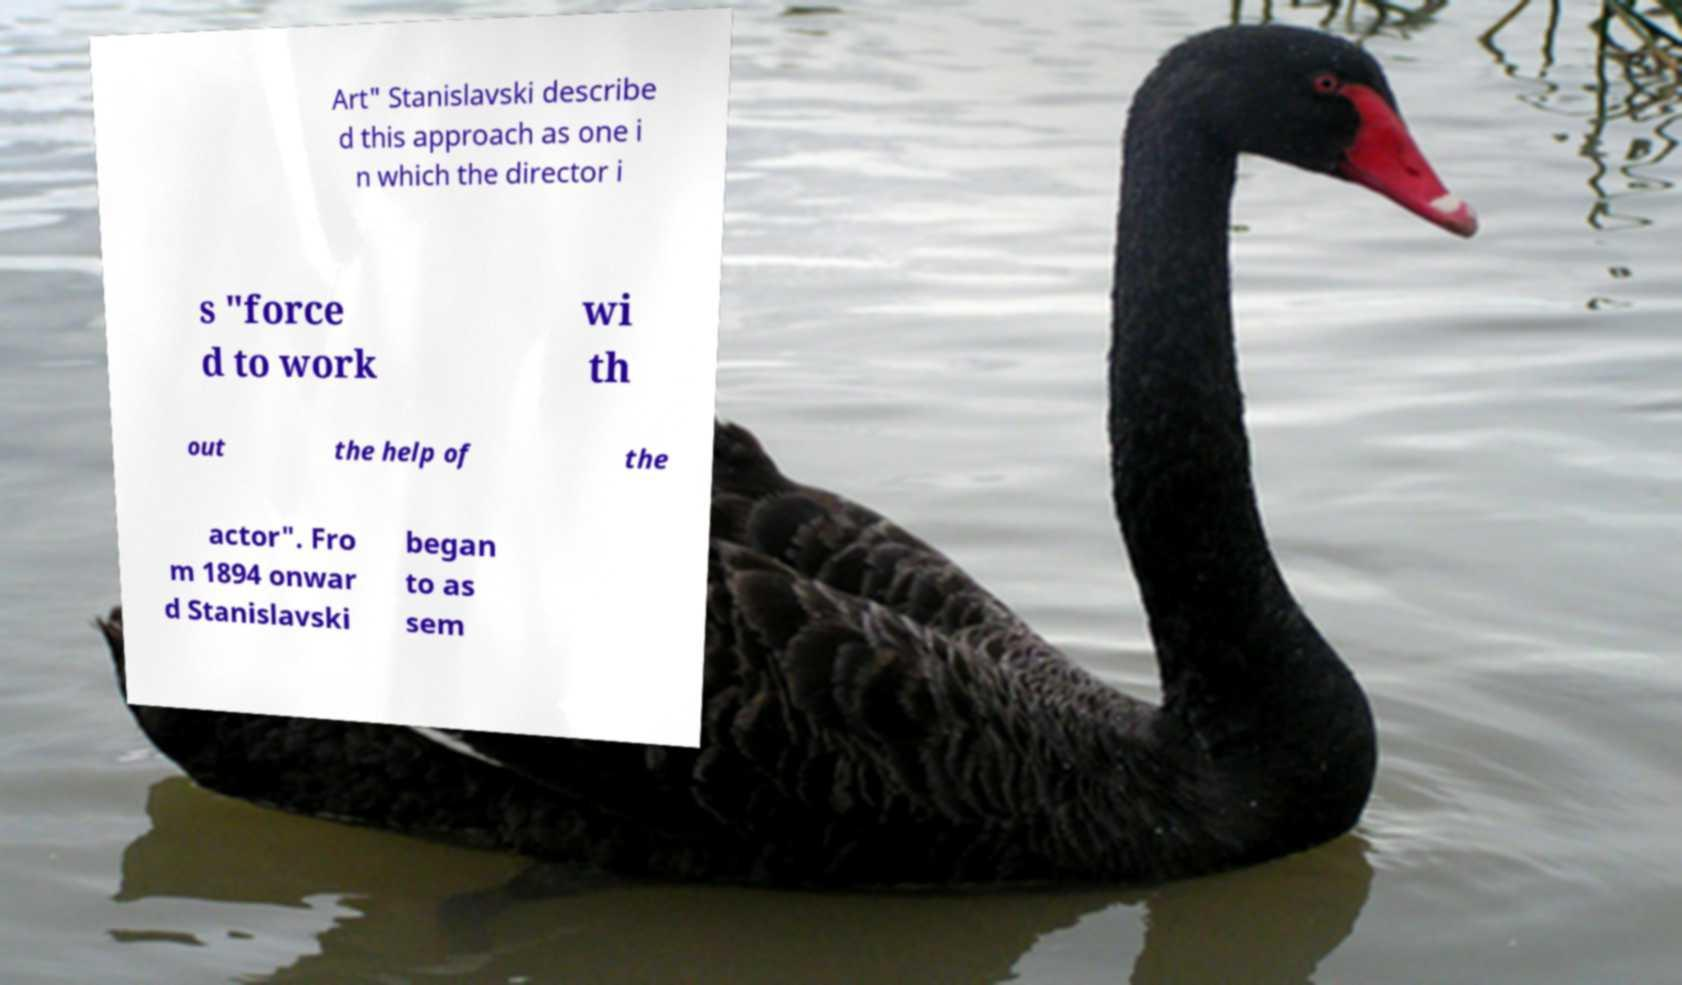Can you accurately transcribe the text from the provided image for me? Art" Stanislavski describe d this approach as one i n which the director i s "force d to work wi th out the help of the actor". Fro m 1894 onwar d Stanislavski began to as sem 